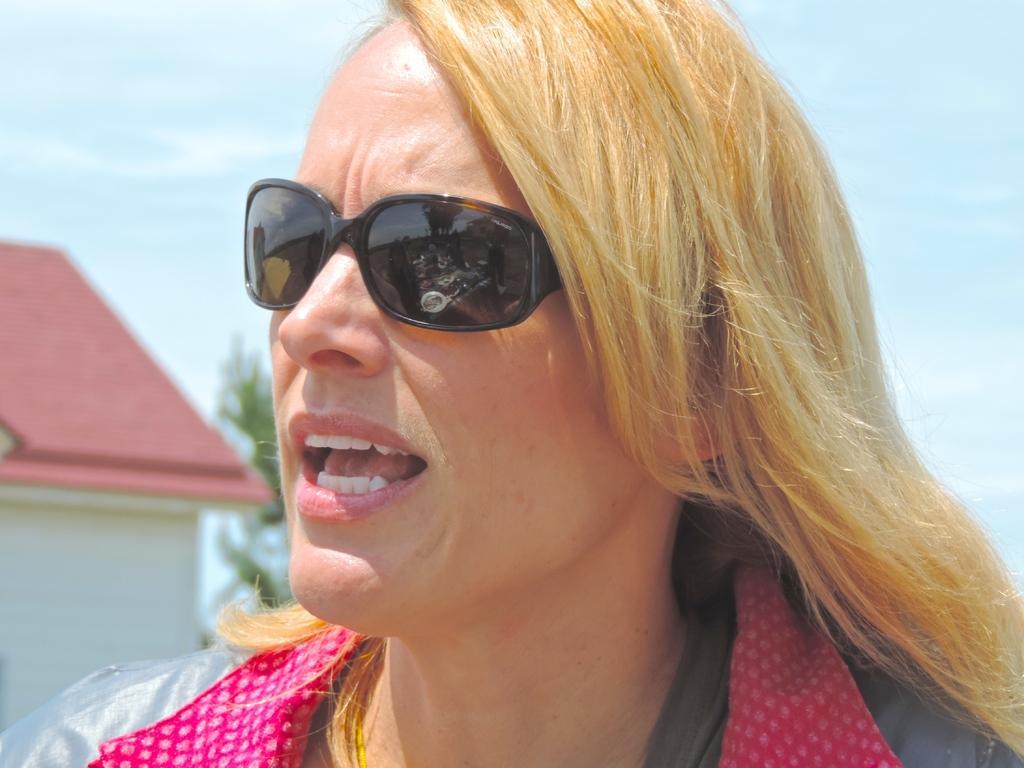Can you describe this image briefly? In this image we can see a woman wearing the goggles and also we can see a house and a tree, in the background, we can see the sky with clouds. 